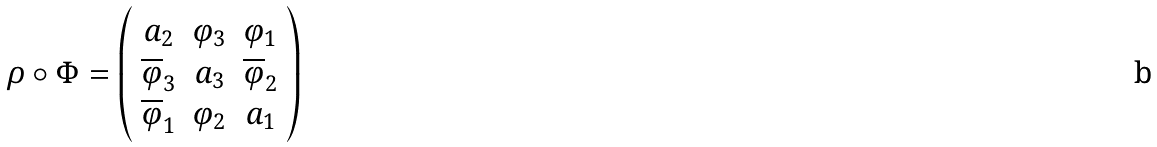<formula> <loc_0><loc_0><loc_500><loc_500>\rho \circ \Phi = \left ( \begin{array} { c c c } a _ { 2 } & \varphi _ { 3 } & \varphi _ { 1 } \\ \overline { \varphi } _ { 3 } & a _ { 3 } & \overline { \varphi } _ { 2 } \\ \overline { \varphi } _ { 1 } & \varphi _ { 2 } & a _ { 1 } \end{array} \right )</formula> 